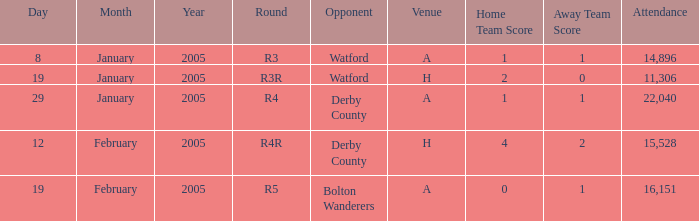Can you give me this table as a dict? {'header': ['Day', 'Month', 'Year', 'Round', 'Opponent', 'Venue', 'Home Team Score', 'Away Team Score', 'Attendance'], 'rows': [['8', 'January', '2005', 'R3', 'Watford', 'A', '1', '1', '14,896'], ['19', 'January', '2005', 'R3R', 'Watford', 'H', '2', '0', '11,306'], ['29', 'January', '2005', 'R4', 'Derby County', 'A', '1', '1', '22,040'], ['12', 'February', '2005', 'R4R', 'Derby County', 'H', '4', '2', '15,528'], ['19', 'February', '2005', 'R5', 'Bolton Wanderers', 'A', '0', '1', '16,151']]} What is the stage of the match at location h and adversary of derby county? R4R. 